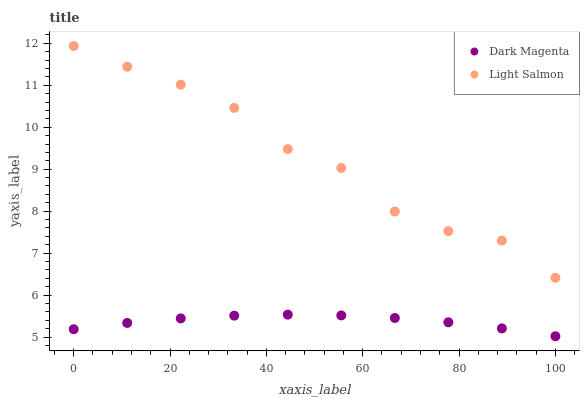Does Dark Magenta have the minimum area under the curve?
Answer yes or no. Yes. Does Light Salmon have the maximum area under the curve?
Answer yes or no. Yes. Does Dark Magenta have the maximum area under the curve?
Answer yes or no. No. Is Dark Magenta the smoothest?
Answer yes or no. Yes. Is Light Salmon the roughest?
Answer yes or no. Yes. Is Dark Magenta the roughest?
Answer yes or no. No. Does Dark Magenta have the lowest value?
Answer yes or no. Yes. Does Light Salmon have the highest value?
Answer yes or no. Yes. Does Dark Magenta have the highest value?
Answer yes or no. No. Is Dark Magenta less than Light Salmon?
Answer yes or no. Yes. Is Light Salmon greater than Dark Magenta?
Answer yes or no. Yes. Does Dark Magenta intersect Light Salmon?
Answer yes or no. No. 